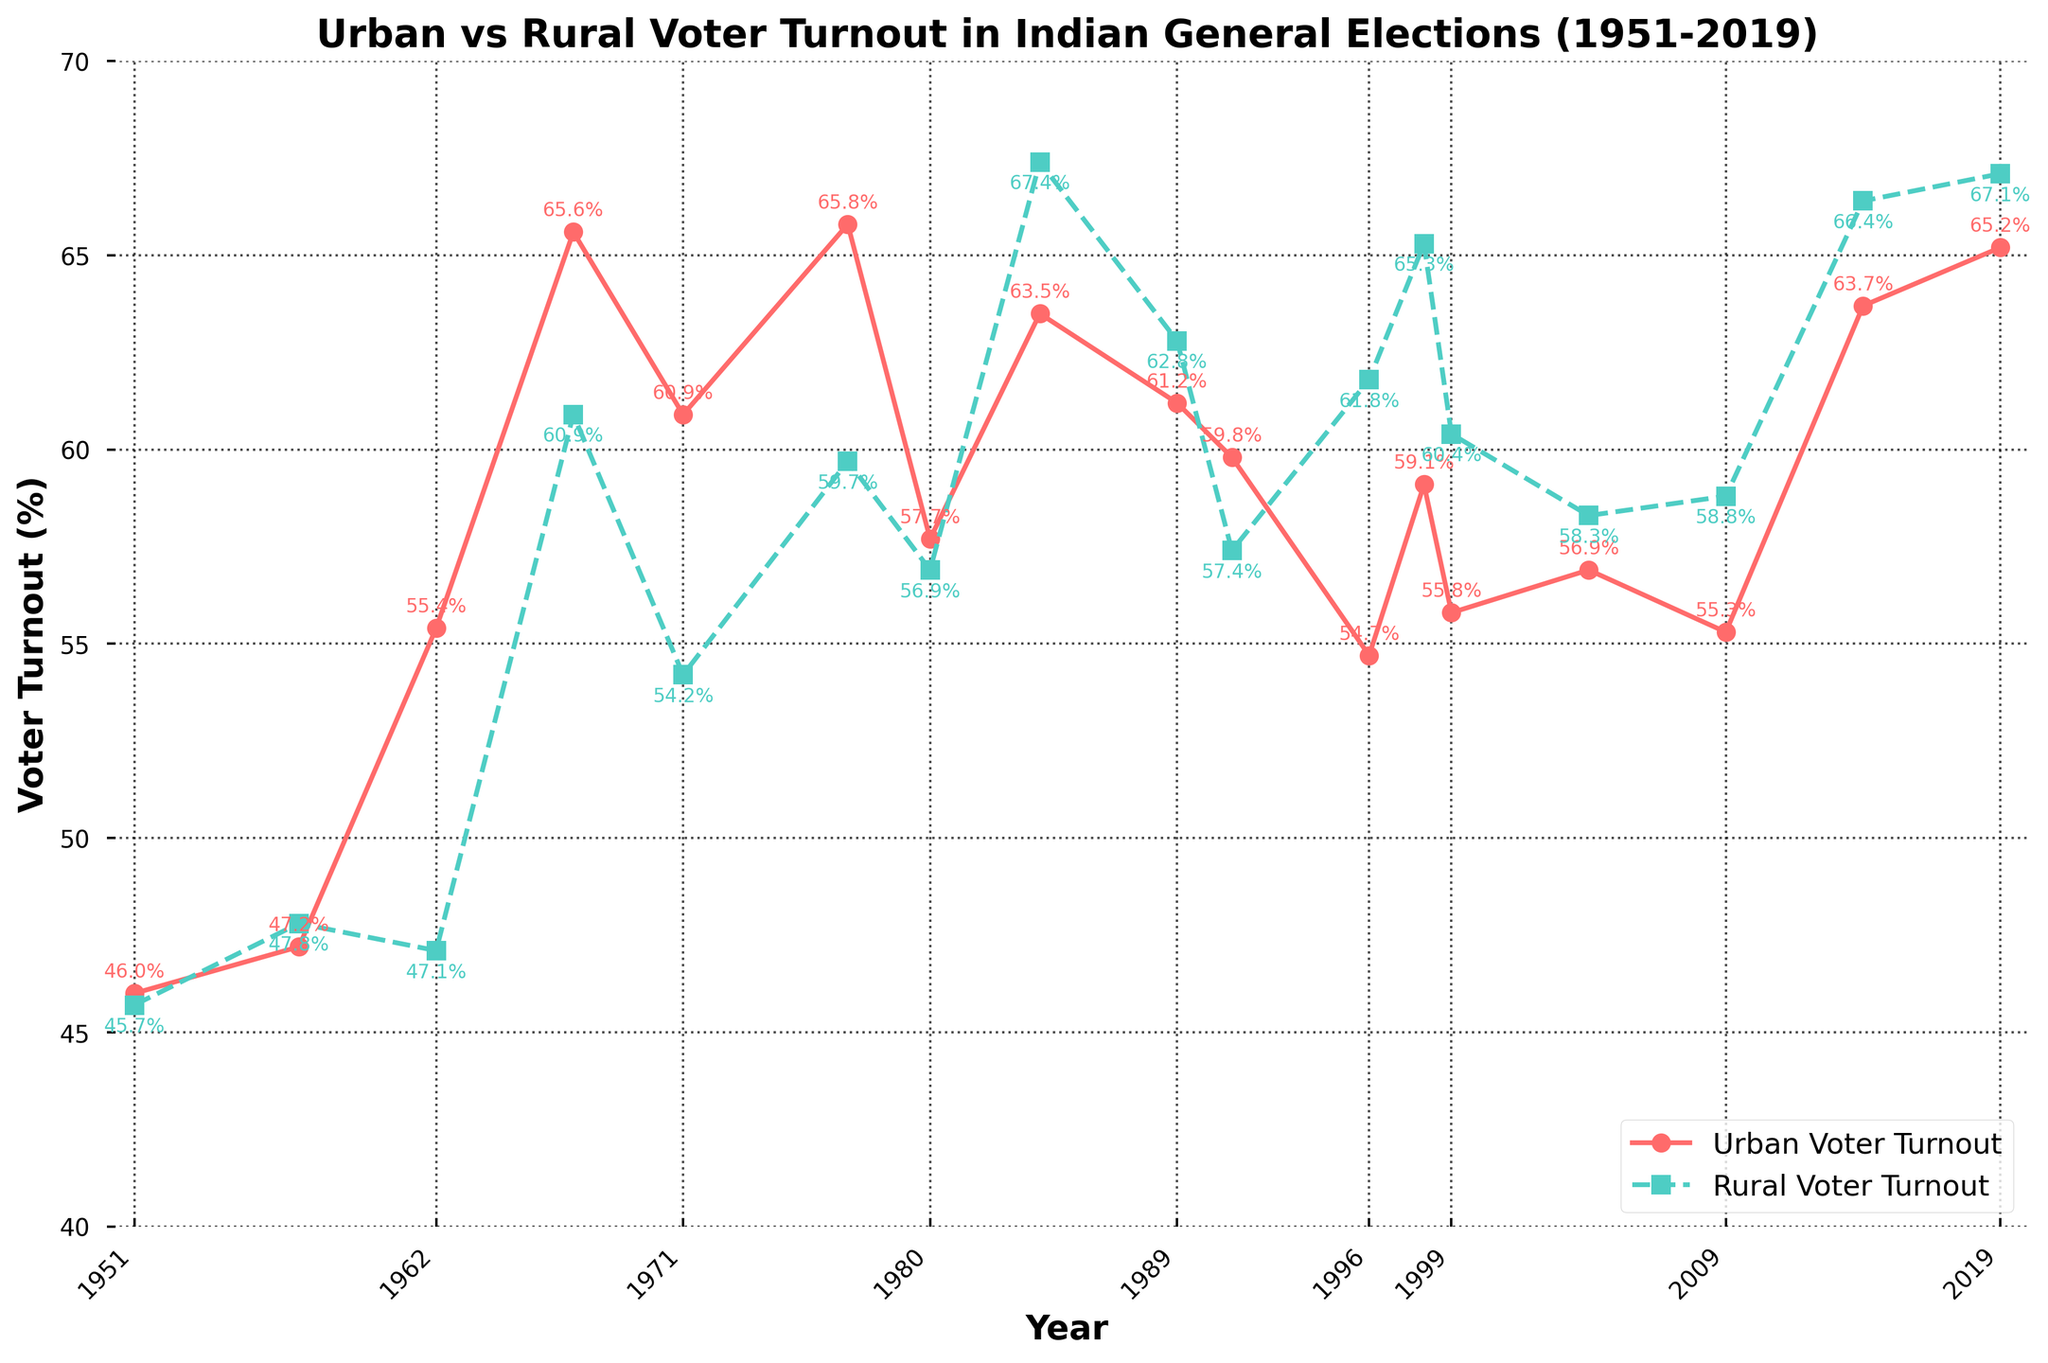Which year had the highest urban voter turnout? The urban voter turnout reached its highest percentage in 1967 at 65.6%, as shown by the peak marked with a red line and a circle in that year.
Answer: 1967 In what year did rural voter turnout first exceed 60%? The rural voter turnout first exceeded 60% in 1967, where it reached 60.9%, indicated by the turquoise-dotted line and square marker.
Answer: 1967 What is the average urban voter turnout percentage from 1951 to 2019? Sum the urban voter turnout percentages from 1951 to 2019, then divide by the number of elections. 
(46.0 + 47.2 + 55.4 + 65.6 + 60.9 + 65.8 + 57.7 + 63.5 + 61.2 + 59.8 + 54.7 + 59.1 + 55.8 + 56.9 + 55.3 + 63.7 + 65.2) / 17 ≈ 58.1
Answer: 58.1% Was rural voter turnout consistently higher or lower than urban voter turnout after 1980? By comparing the trends in the figure from 1984 to 2019, rural voter turnout (in turquoise) was consistently higher than urban voter turnout (in red).
Answer: Higher How much did urban voter turnout increase from 1957 to 1967? Subtract the urban voter turnout in 1957 from the turnout in 1967: 65.6 - 47.2 = 18.4%.
Answer: 18.4% Which year exhibited the greatest difference between urban and rural voter turnout? The greatest difference appears in 1984 where the rural turnout was 67.4% and the urban turnout was 63.5%. The difference is 67.4 - 63.5 = 3.9%.
Answer: 1984 In which two consecutive election years did the urban voter turnout decrease for both? From 1977 to 1980 (65.8% to 57.7%) and from 1980 to 1984 (57.7% to 63.5%). These consecutive declines are highlighted by the red line peaking and followed by two downward trends.
Answer: 1977-1980 During which years did rural voter turnout surpass the 65% mark? Rural voter turnout exceeded 65% in the years 1984, 1998, 2014, and 2019. These years are clearly marked with turquoise squares above the 65% line.
Answer: 1984, 1998, 2014, 2019 What are the years where urban and rural voter turnouts are relatively close to each other? In 1951, the urban and rural voter turnouts were very close, 46.0% and 45.7%, respectively. This is shown by nearly overlapping markers at the start of the graph.
Answer: 1951 In which election year did urban voter turnout decrease while rural voter turnout increased? This phenomenon occurred in 1996 when urban voter turnout decreased to 54.7%, while rural voter turnout increased to 61.8%. These opposing trends are indicated by the red line decreasing while the turquoise line increases.
Answer: 1996 